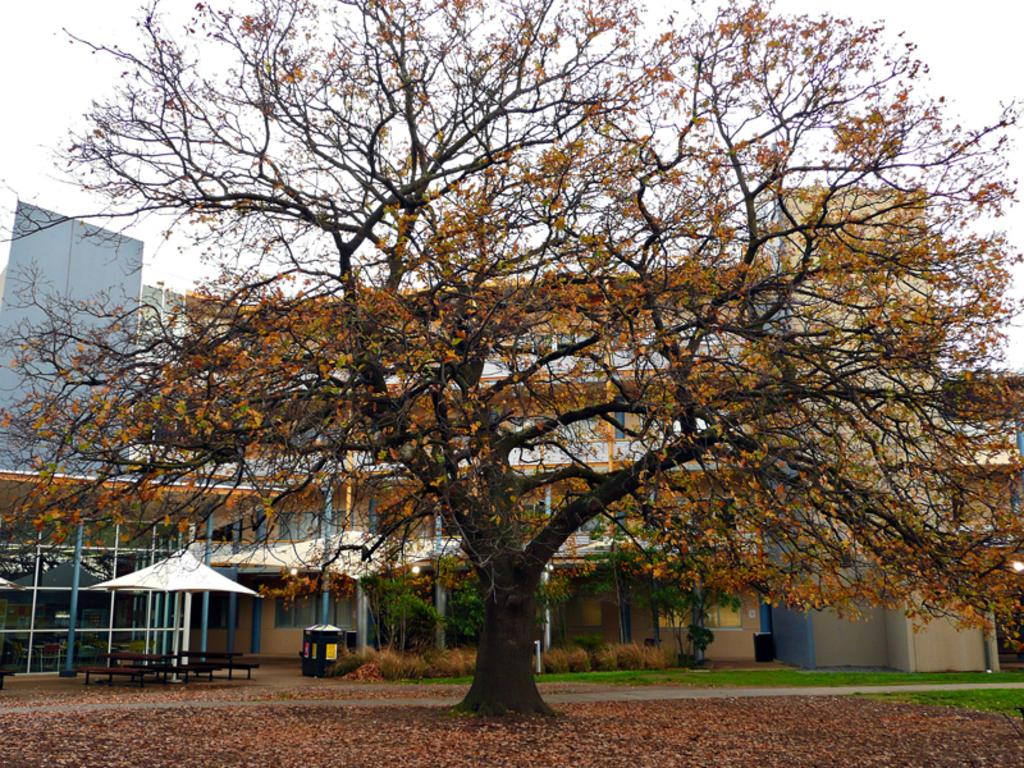What type of vegetation can be seen in the image? There are trees and grass in the image. What is located in front of the image? There are plants in front of the image. What can be seen in the background of the image? There are buildings and the sky in the background of the image. How is the sky depicted in the image? The sky is clear and visible in the background of the image. What type of yoke is being used by the trees in the image? There is no yoke present in the image, as yokes are typically used for animals, not trees. Can you see any bats flying in the image? There are no bats visible in the image. 